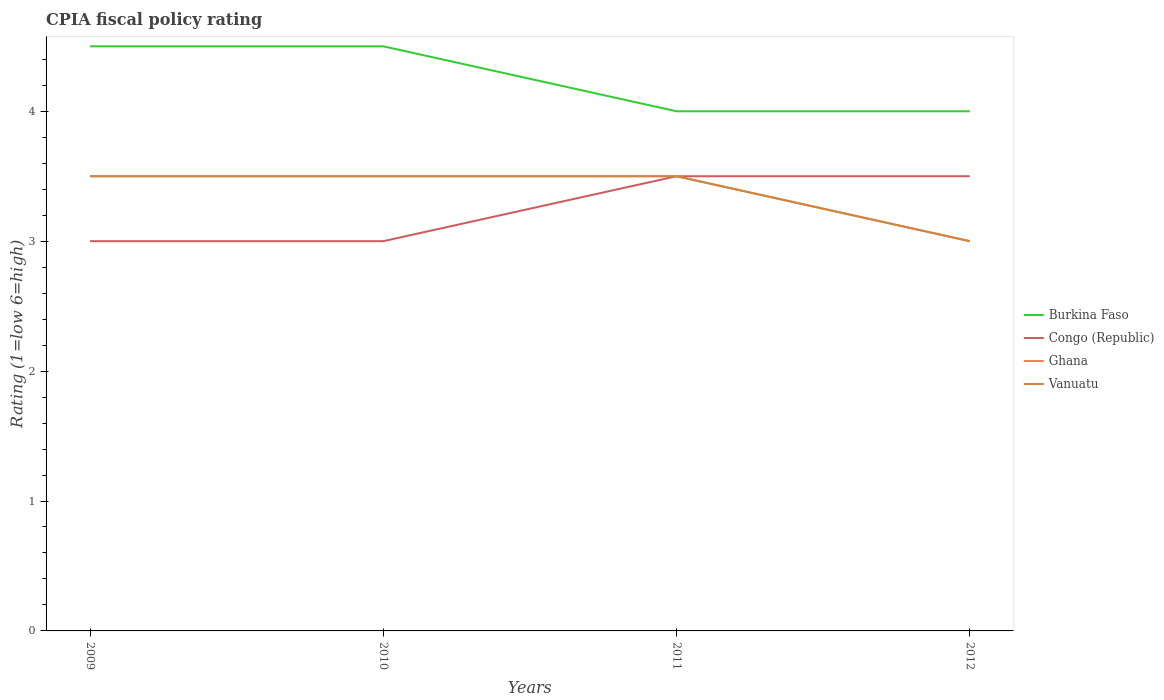Does the line corresponding to Burkina Faso intersect with the line corresponding to Vanuatu?
Provide a succinct answer. No. Is the number of lines equal to the number of legend labels?
Provide a short and direct response. Yes. In which year was the CPIA rating in Congo (Republic) maximum?
Provide a short and direct response. 2009. What is the total CPIA rating in Congo (Republic) in the graph?
Make the answer very short. -0.5. What is the difference between the highest and the lowest CPIA rating in Burkina Faso?
Give a very brief answer. 2. Is the CPIA rating in Ghana strictly greater than the CPIA rating in Congo (Republic) over the years?
Provide a succinct answer. No. How many years are there in the graph?
Give a very brief answer. 4. Are the values on the major ticks of Y-axis written in scientific E-notation?
Provide a succinct answer. No. Does the graph contain any zero values?
Your response must be concise. No. How many legend labels are there?
Your answer should be very brief. 4. How are the legend labels stacked?
Your response must be concise. Vertical. What is the title of the graph?
Offer a terse response. CPIA fiscal policy rating. What is the Rating (1=low 6=high) of Burkina Faso in 2009?
Offer a very short reply. 4.5. What is the Rating (1=low 6=high) in Congo (Republic) in 2009?
Provide a short and direct response. 3. What is the Rating (1=low 6=high) of Ghana in 2009?
Provide a short and direct response. 3.5. What is the Rating (1=low 6=high) in Burkina Faso in 2010?
Your answer should be very brief. 4.5. What is the Rating (1=low 6=high) in Congo (Republic) in 2010?
Provide a short and direct response. 3. What is the Rating (1=low 6=high) of Vanuatu in 2011?
Offer a terse response. 3.5. What is the Rating (1=low 6=high) in Burkina Faso in 2012?
Your answer should be compact. 4. What is the Rating (1=low 6=high) of Congo (Republic) in 2012?
Provide a succinct answer. 3.5. Across all years, what is the maximum Rating (1=low 6=high) in Burkina Faso?
Offer a very short reply. 4.5. Across all years, what is the maximum Rating (1=low 6=high) in Vanuatu?
Your response must be concise. 3.5. Across all years, what is the minimum Rating (1=low 6=high) in Burkina Faso?
Provide a succinct answer. 4. Across all years, what is the minimum Rating (1=low 6=high) of Congo (Republic)?
Offer a very short reply. 3. Across all years, what is the minimum Rating (1=low 6=high) in Vanuatu?
Offer a very short reply. 3. What is the total Rating (1=low 6=high) of Burkina Faso in the graph?
Offer a very short reply. 17. What is the total Rating (1=low 6=high) of Congo (Republic) in the graph?
Offer a very short reply. 13. What is the difference between the Rating (1=low 6=high) of Congo (Republic) in 2009 and that in 2010?
Offer a very short reply. 0. What is the difference between the Rating (1=low 6=high) of Vanuatu in 2009 and that in 2010?
Provide a succinct answer. 0. What is the difference between the Rating (1=low 6=high) in Burkina Faso in 2009 and that in 2011?
Offer a very short reply. 0.5. What is the difference between the Rating (1=low 6=high) in Congo (Republic) in 2009 and that in 2011?
Ensure brevity in your answer.  -0.5. What is the difference between the Rating (1=low 6=high) of Burkina Faso in 2009 and that in 2012?
Make the answer very short. 0.5. What is the difference between the Rating (1=low 6=high) in Congo (Republic) in 2009 and that in 2012?
Offer a terse response. -0.5. What is the difference between the Rating (1=low 6=high) of Ghana in 2009 and that in 2012?
Make the answer very short. 0.5. What is the difference between the Rating (1=low 6=high) of Congo (Republic) in 2010 and that in 2011?
Provide a succinct answer. -0.5. What is the difference between the Rating (1=low 6=high) of Ghana in 2010 and that in 2011?
Offer a very short reply. 0. What is the difference between the Rating (1=low 6=high) in Vanuatu in 2010 and that in 2011?
Your answer should be very brief. 0. What is the difference between the Rating (1=low 6=high) in Vanuatu in 2010 and that in 2012?
Provide a short and direct response. 0.5. What is the difference between the Rating (1=low 6=high) in Burkina Faso in 2011 and that in 2012?
Your response must be concise. 0. What is the difference between the Rating (1=low 6=high) of Congo (Republic) in 2011 and that in 2012?
Give a very brief answer. 0. What is the difference between the Rating (1=low 6=high) of Ghana in 2011 and that in 2012?
Ensure brevity in your answer.  0.5. What is the difference between the Rating (1=low 6=high) in Burkina Faso in 2009 and the Rating (1=low 6=high) in Congo (Republic) in 2010?
Keep it short and to the point. 1.5. What is the difference between the Rating (1=low 6=high) of Burkina Faso in 2009 and the Rating (1=low 6=high) of Ghana in 2010?
Give a very brief answer. 1. What is the difference between the Rating (1=low 6=high) of Congo (Republic) in 2009 and the Rating (1=low 6=high) of Ghana in 2010?
Make the answer very short. -0.5. What is the difference between the Rating (1=low 6=high) in Burkina Faso in 2009 and the Rating (1=low 6=high) in Ghana in 2011?
Offer a very short reply. 1. What is the difference between the Rating (1=low 6=high) in Congo (Republic) in 2009 and the Rating (1=low 6=high) in Ghana in 2011?
Give a very brief answer. -0.5. What is the difference between the Rating (1=low 6=high) of Ghana in 2009 and the Rating (1=low 6=high) of Vanuatu in 2011?
Offer a terse response. 0. What is the difference between the Rating (1=low 6=high) of Burkina Faso in 2010 and the Rating (1=low 6=high) of Congo (Republic) in 2011?
Keep it short and to the point. 1. What is the difference between the Rating (1=low 6=high) of Burkina Faso in 2010 and the Rating (1=low 6=high) of Ghana in 2011?
Your answer should be compact. 1. What is the difference between the Rating (1=low 6=high) of Ghana in 2010 and the Rating (1=low 6=high) of Vanuatu in 2011?
Provide a succinct answer. 0. What is the difference between the Rating (1=low 6=high) in Burkina Faso in 2010 and the Rating (1=low 6=high) in Congo (Republic) in 2012?
Your answer should be compact. 1. What is the difference between the Rating (1=low 6=high) in Burkina Faso in 2011 and the Rating (1=low 6=high) in Congo (Republic) in 2012?
Make the answer very short. 0.5. What is the difference between the Rating (1=low 6=high) of Burkina Faso in 2011 and the Rating (1=low 6=high) of Vanuatu in 2012?
Give a very brief answer. 1. What is the difference between the Rating (1=low 6=high) in Congo (Republic) in 2011 and the Rating (1=low 6=high) in Ghana in 2012?
Ensure brevity in your answer.  0.5. What is the difference between the Rating (1=low 6=high) in Congo (Republic) in 2011 and the Rating (1=low 6=high) in Vanuatu in 2012?
Give a very brief answer. 0.5. What is the difference between the Rating (1=low 6=high) of Ghana in 2011 and the Rating (1=low 6=high) of Vanuatu in 2012?
Give a very brief answer. 0.5. What is the average Rating (1=low 6=high) in Burkina Faso per year?
Provide a short and direct response. 4.25. What is the average Rating (1=low 6=high) in Ghana per year?
Give a very brief answer. 3.38. What is the average Rating (1=low 6=high) in Vanuatu per year?
Your answer should be compact. 3.38. In the year 2009, what is the difference between the Rating (1=low 6=high) in Burkina Faso and Rating (1=low 6=high) in Ghana?
Your answer should be very brief. 1. In the year 2009, what is the difference between the Rating (1=low 6=high) in Burkina Faso and Rating (1=low 6=high) in Vanuatu?
Provide a short and direct response. 1. In the year 2010, what is the difference between the Rating (1=low 6=high) in Burkina Faso and Rating (1=low 6=high) in Congo (Republic)?
Provide a short and direct response. 1.5. In the year 2010, what is the difference between the Rating (1=low 6=high) in Burkina Faso and Rating (1=low 6=high) in Ghana?
Make the answer very short. 1. In the year 2010, what is the difference between the Rating (1=low 6=high) of Burkina Faso and Rating (1=low 6=high) of Vanuatu?
Your answer should be compact. 1. In the year 2010, what is the difference between the Rating (1=low 6=high) in Congo (Republic) and Rating (1=low 6=high) in Ghana?
Your answer should be very brief. -0.5. In the year 2010, what is the difference between the Rating (1=low 6=high) of Ghana and Rating (1=low 6=high) of Vanuatu?
Ensure brevity in your answer.  0. In the year 2011, what is the difference between the Rating (1=low 6=high) in Burkina Faso and Rating (1=low 6=high) in Ghana?
Your response must be concise. 0.5. In the year 2011, what is the difference between the Rating (1=low 6=high) of Burkina Faso and Rating (1=low 6=high) of Vanuatu?
Offer a terse response. 0.5. In the year 2011, what is the difference between the Rating (1=low 6=high) of Congo (Republic) and Rating (1=low 6=high) of Ghana?
Provide a succinct answer. 0. In the year 2011, what is the difference between the Rating (1=low 6=high) in Congo (Republic) and Rating (1=low 6=high) in Vanuatu?
Your answer should be very brief. 0. In the year 2011, what is the difference between the Rating (1=low 6=high) of Ghana and Rating (1=low 6=high) of Vanuatu?
Make the answer very short. 0. In the year 2012, what is the difference between the Rating (1=low 6=high) of Burkina Faso and Rating (1=low 6=high) of Congo (Republic)?
Offer a very short reply. 0.5. In the year 2012, what is the difference between the Rating (1=low 6=high) in Burkina Faso and Rating (1=low 6=high) in Vanuatu?
Provide a short and direct response. 1. What is the ratio of the Rating (1=low 6=high) of Burkina Faso in 2009 to that in 2010?
Your answer should be very brief. 1. What is the ratio of the Rating (1=low 6=high) in Ghana in 2009 to that in 2011?
Your response must be concise. 1. What is the ratio of the Rating (1=low 6=high) in Vanuatu in 2009 to that in 2011?
Your answer should be compact. 1. What is the ratio of the Rating (1=low 6=high) of Ghana in 2009 to that in 2012?
Your answer should be compact. 1.17. What is the ratio of the Rating (1=low 6=high) of Vanuatu in 2009 to that in 2012?
Offer a very short reply. 1.17. What is the ratio of the Rating (1=low 6=high) of Burkina Faso in 2010 to that in 2011?
Make the answer very short. 1.12. What is the ratio of the Rating (1=low 6=high) in Vanuatu in 2010 to that in 2011?
Ensure brevity in your answer.  1. What is the ratio of the Rating (1=low 6=high) in Burkina Faso in 2010 to that in 2012?
Offer a terse response. 1.12. What is the ratio of the Rating (1=low 6=high) of Burkina Faso in 2011 to that in 2012?
Provide a short and direct response. 1. What is the ratio of the Rating (1=low 6=high) of Congo (Republic) in 2011 to that in 2012?
Provide a short and direct response. 1. What is the ratio of the Rating (1=low 6=high) of Ghana in 2011 to that in 2012?
Your answer should be very brief. 1.17. What is the ratio of the Rating (1=low 6=high) in Vanuatu in 2011 to that in 2012?
Provide a short and direct response. 1.17. What is the difference between the highest and the second highest Rating (1=low 6=high) of Burkina Faso?
Offer a very short reply. 0. What is the difference between the highest and the second highest Rating (1=low 6=high) of Congo (Republic)?
Give a very brief answer. 0. What is the difference between the highest and the second highest Rating (1=low 6=high) of Vanuatu?
Offer a very short reply. 0. What is the difference between the highest and the lowest Rating (1=low 6=high) of Burkina Faso?
Make the answer very short. 0.5. What is the difference between the highest and the lowest Rating (1=low 6=high) in Congo (Republic)?
Offer a very short reply. 0.5. What is the difference between the highest and the lowest Rating (1=low 6=high) in Ghana?
Your response must be concise. 0.5. 